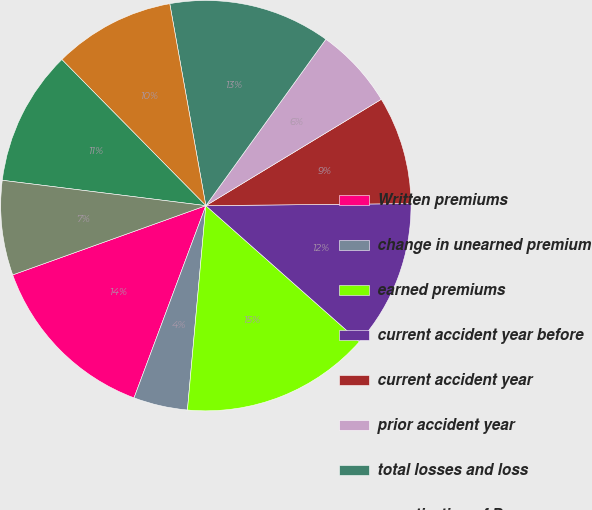Convert chart to OTSL. <chart><loc_0><loc_0><loc_500><loc_500><pie_chart><fcel>Written premiums<fcel>change in unearned premium<fcel>earned premiums<fcel>current accident year before<fcel>current accident year<fcel>prior accident year<fcel>total losses and loss<fcel>amortization of Dac<fcel>underwriting expenses<fcel>Underwriting gain (loss)<nl><fcel>13.83%<fcel>4.26%<fcel>14.89%<fcel>11.7%<fcel>8.51%<fcel>6.38%<fcel>12.76%<fcel>9.57%<fcel>10.64%<fcel>7.45%<nl></chart> 